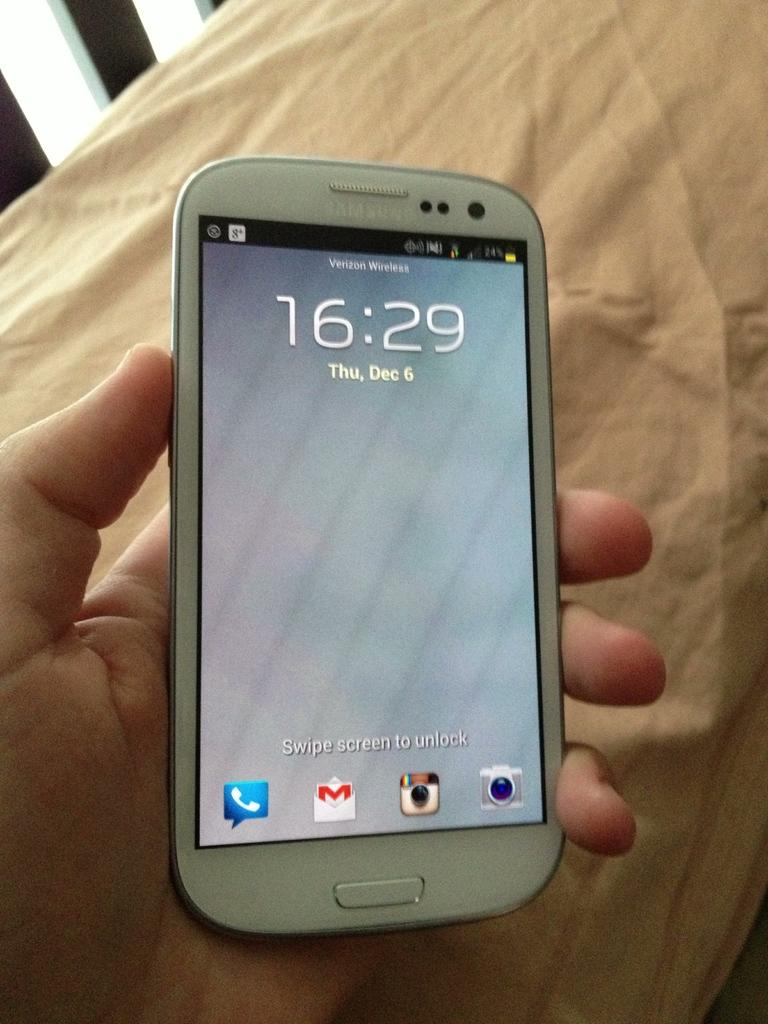<image>
Present a compact description of the photo's key features. a white samsung smart phone displaying 16:29 and Thu, Dec 6 